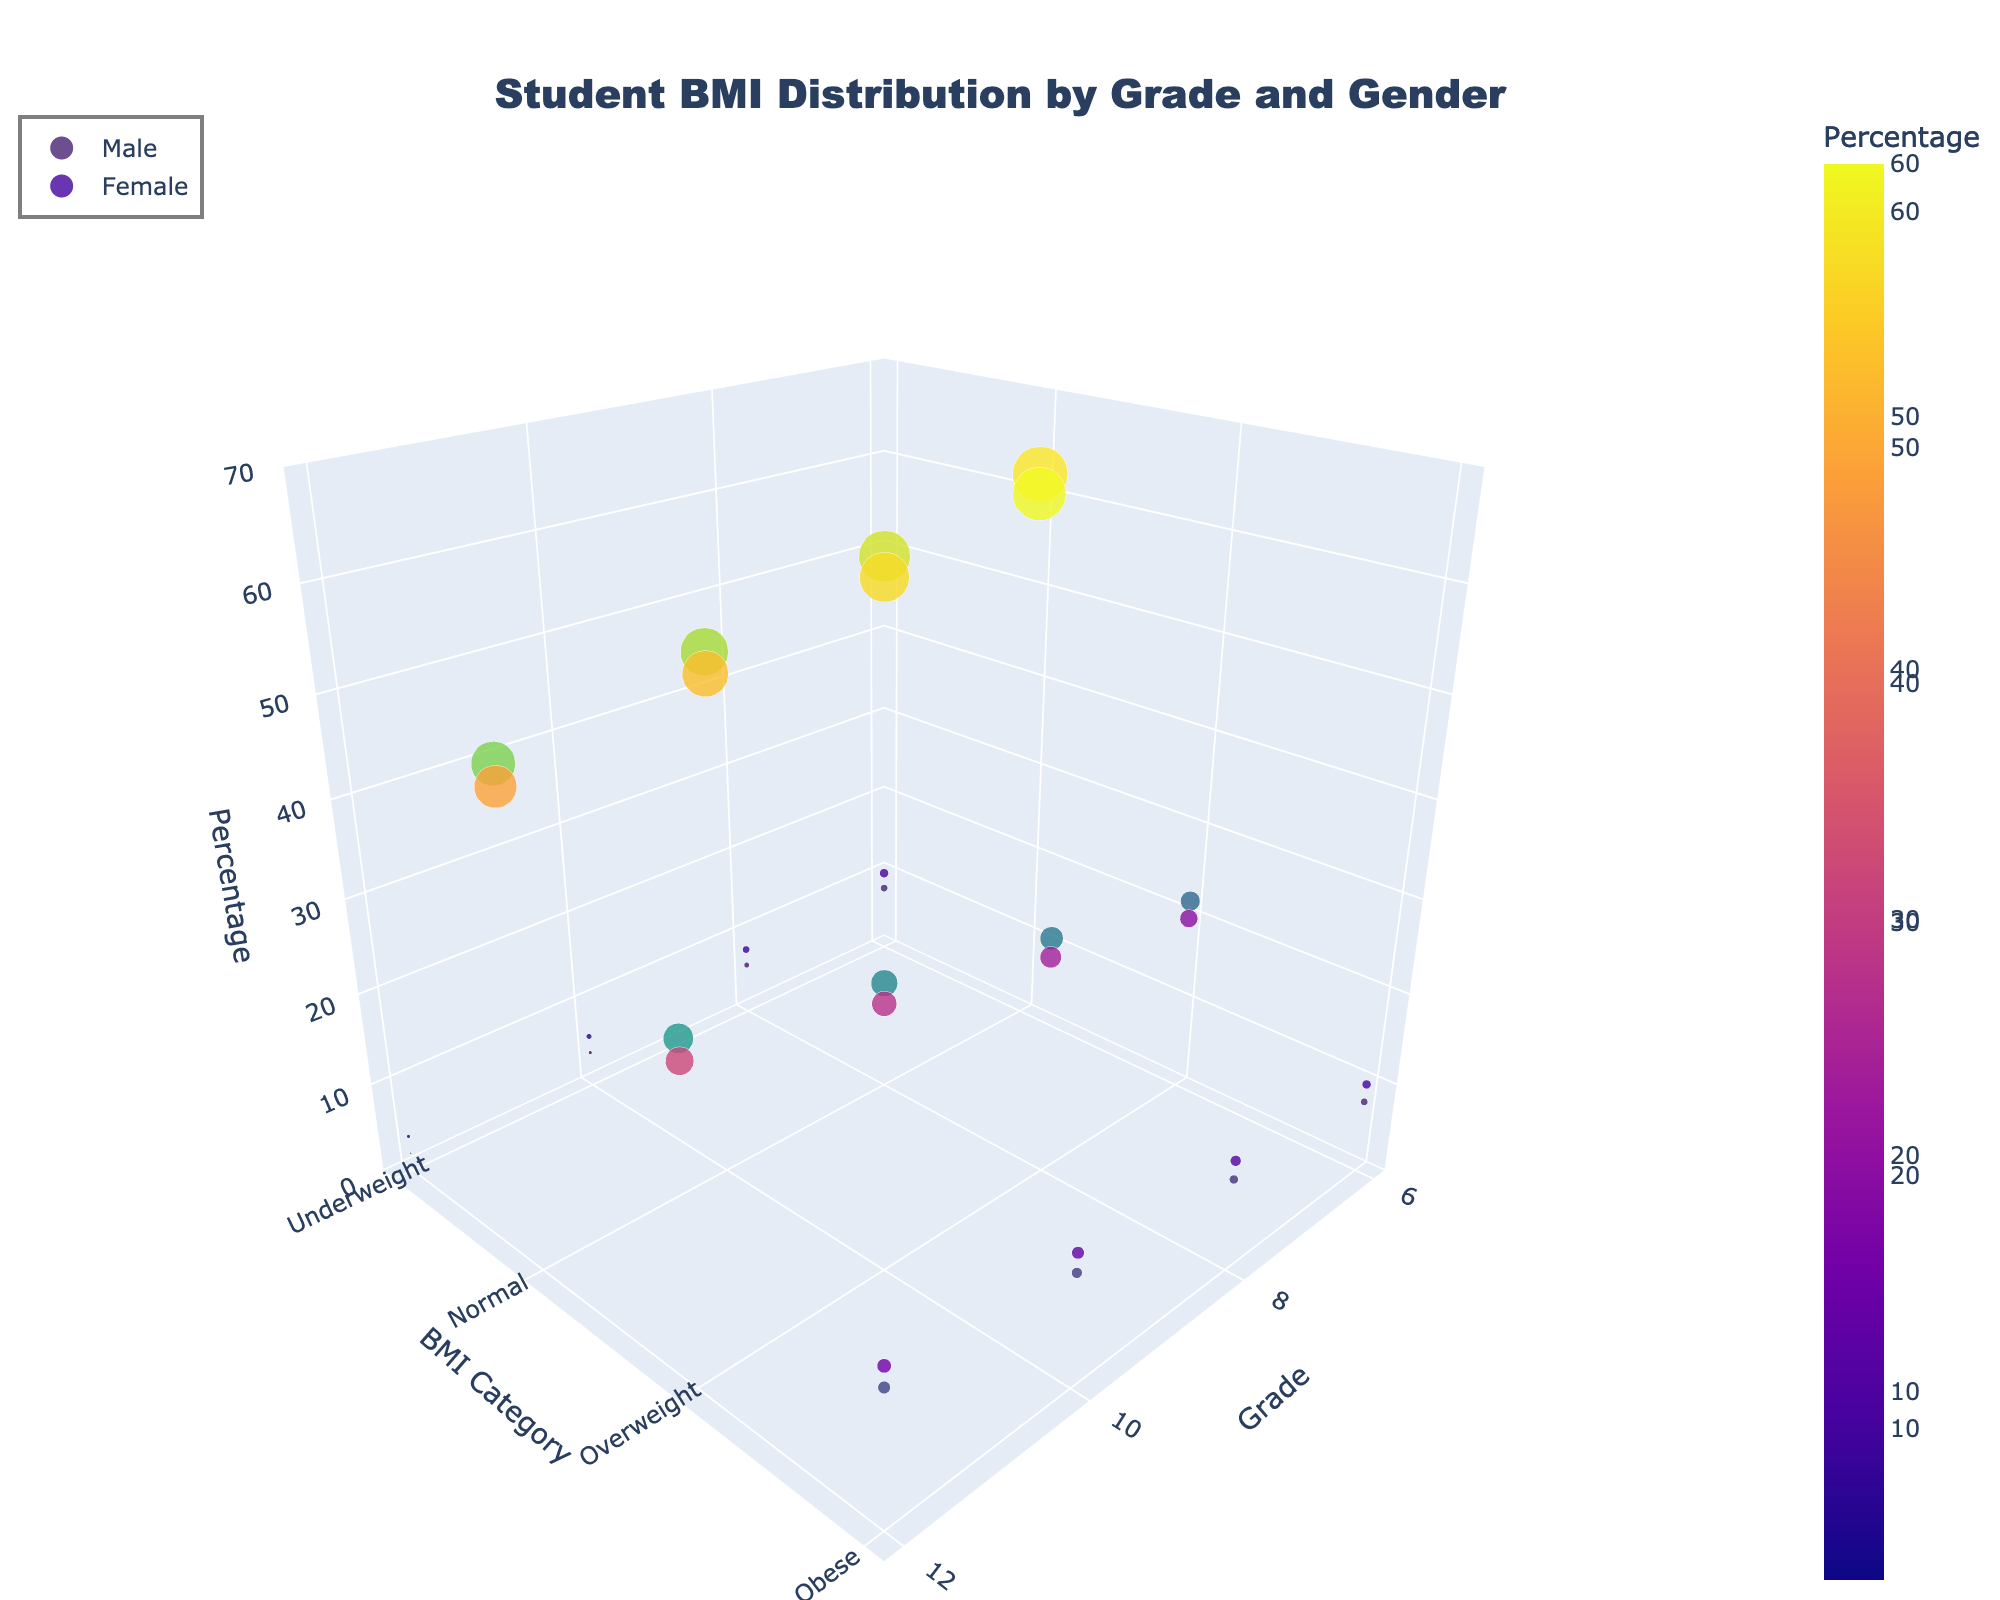Which BMI category has the highest percentage for 6th grade males? To find the highest percentage for 6th grade males, look at the 3D plot's section for 6th grade, male gender, then compare the percentages for each BMI category. The Normal category has the highest percentage.
Answer: Normal What is the difference in the percentage of obese students between male and female in 12th grade? Look at the 3D plot's section for 12th grade, then pinpoint the Obese category for both males and females. The percentages for males and females are 14% and 16% respectively. The difference is 16% - 14% = 2%.
Answer: 2% Which grade level has the highest percentage of underweight males? Observe the sections corresponding to each grade level for underweight males on the 3D plot. The percentages are: 6th (8%), 8th (6%), 10th (4%), and 12th (2%). The highest percentage is in the 6th grade.
Answer: 6th Is the percentage of overweight females greater in the 10th grade compared to the 8th grade? Compare the percentage of overweight females in the 10th grade (28%) with the 8th grade (24%) as shown in the 3D plot. Since 28% > 24%, the percentage is indeed greater.
Answer: Yes What is the combined percentage of normal BMI students across all grades for females? Add the percentage of females in the Normal BMI category across all grades: 6th (60%) + 8th (56%) + 10th (52%) + 12th (48%) = 216%.
Answer: 216% From which grade to which grade does the percentage of normal BMI males decrease the most? Analyze the Normal BMI category for males across all grades: 6th (62%), 8th (58%), 10th (54%), and 12th (50%). The decrease between each consecutive grade is 4%. The total decrease from 6th to 12th is 62% - 50% = 12%.
Answer: 6th to 12th In which grade is the percentage difference between overweight males and females largest? Calculate the difference in overweight percentages between males and females in each grade: 6th (22% - 20% = 2%), 8th (26% - 24% = 2%), 10th (30% - 28% = 2%), and 12th (34% - 32% = 2%). The differences are all equal at 2%.
Answer: All grades equally How does the percentage of 8th grade females in the obese category compare to 10th grade males in the same category? Compare the percentages of obese category: 8th grade females (12%) and 10th grade males (12%). They are equal.
Answer: Equal 